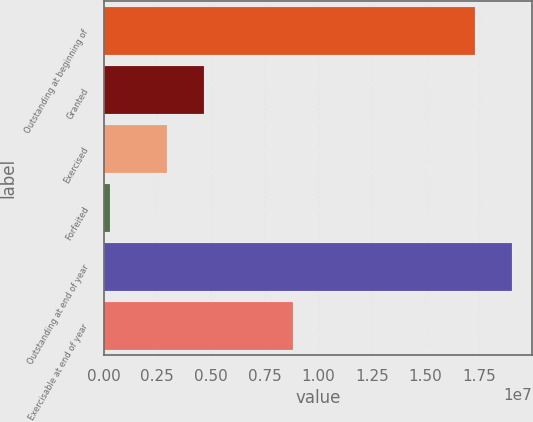<chart> <loc_0><loc_0><loc_500><loc_500><bar_chart><fcel>Outstanding at beginning of<fcel>Granted<fcel>Exercised<fcel>Forfeited<fcel>Outstanding at end of year<fcel>Exercisable at end of year<nl><fcel>1.7306e+07<fcel>4.65251e+06<fcel>2.95115e+06<fcel>301544<fcel>1.90074e+07<fcel>8.82952e+06<nl></chart> 